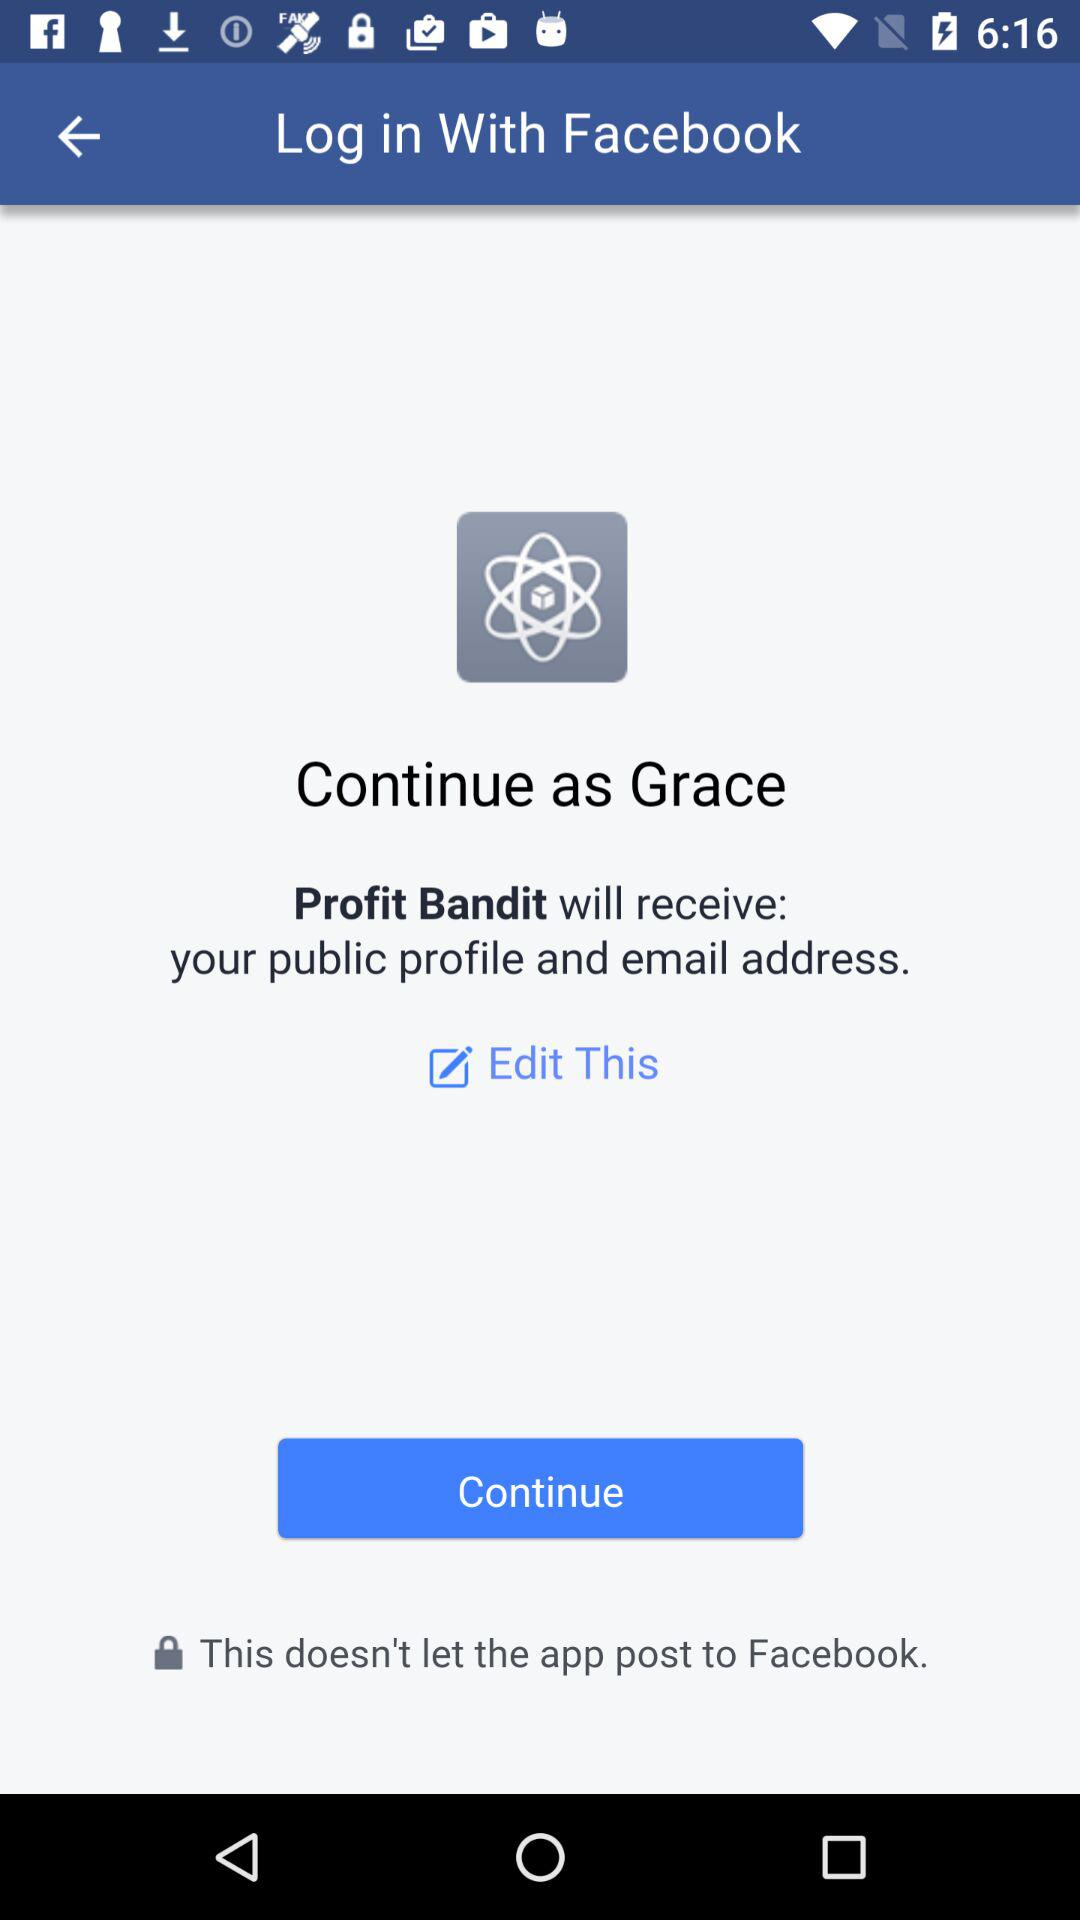What application is used to login? The application is "Facebook". 